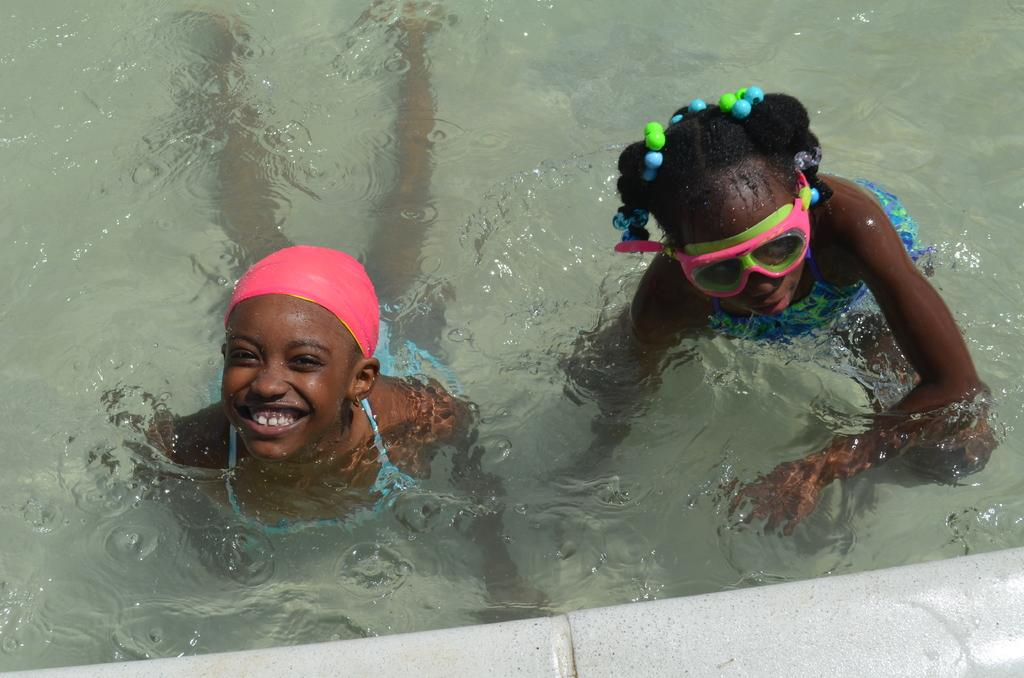How many people are in the image? There are two girls in the image. What are the girls doing in the image? The girls are in a swimming pool. What type of oil can be seen floating on the surface of the girls' eyes in the image? There is no oil or reference to eyes in the image; the girls are in a swimming pool. 